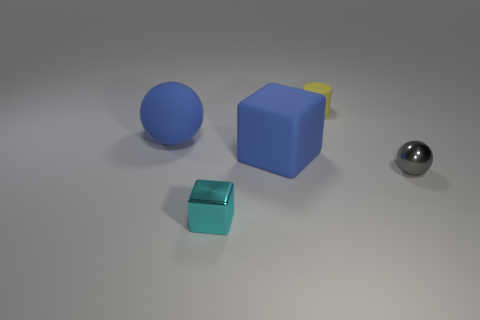Subtract all blue spheres. How many spheres are left? 1 Subtract all cylinders. How many objects are left? 4 Subtract all brown cylinders. How many cyan spheres are left? 0 Subtract all metallic blocks. Subtract all small gray metal things. How many objects are left? 3 Add 2 large blue cubes. How many large blue cubes are left? 3 Add 1 yellow objects. How many yellow objects exist? 2 Add 5 tiny yellow cylinders. How many objects exist? 10 Subtract 0 cyan spheres. How many objects are left? 5 Subtract 1 cylinders. How many cylinders are left? 0 Subtract all gray cylinders. Subtract all brown blocks. How many cylinders are left? 1 